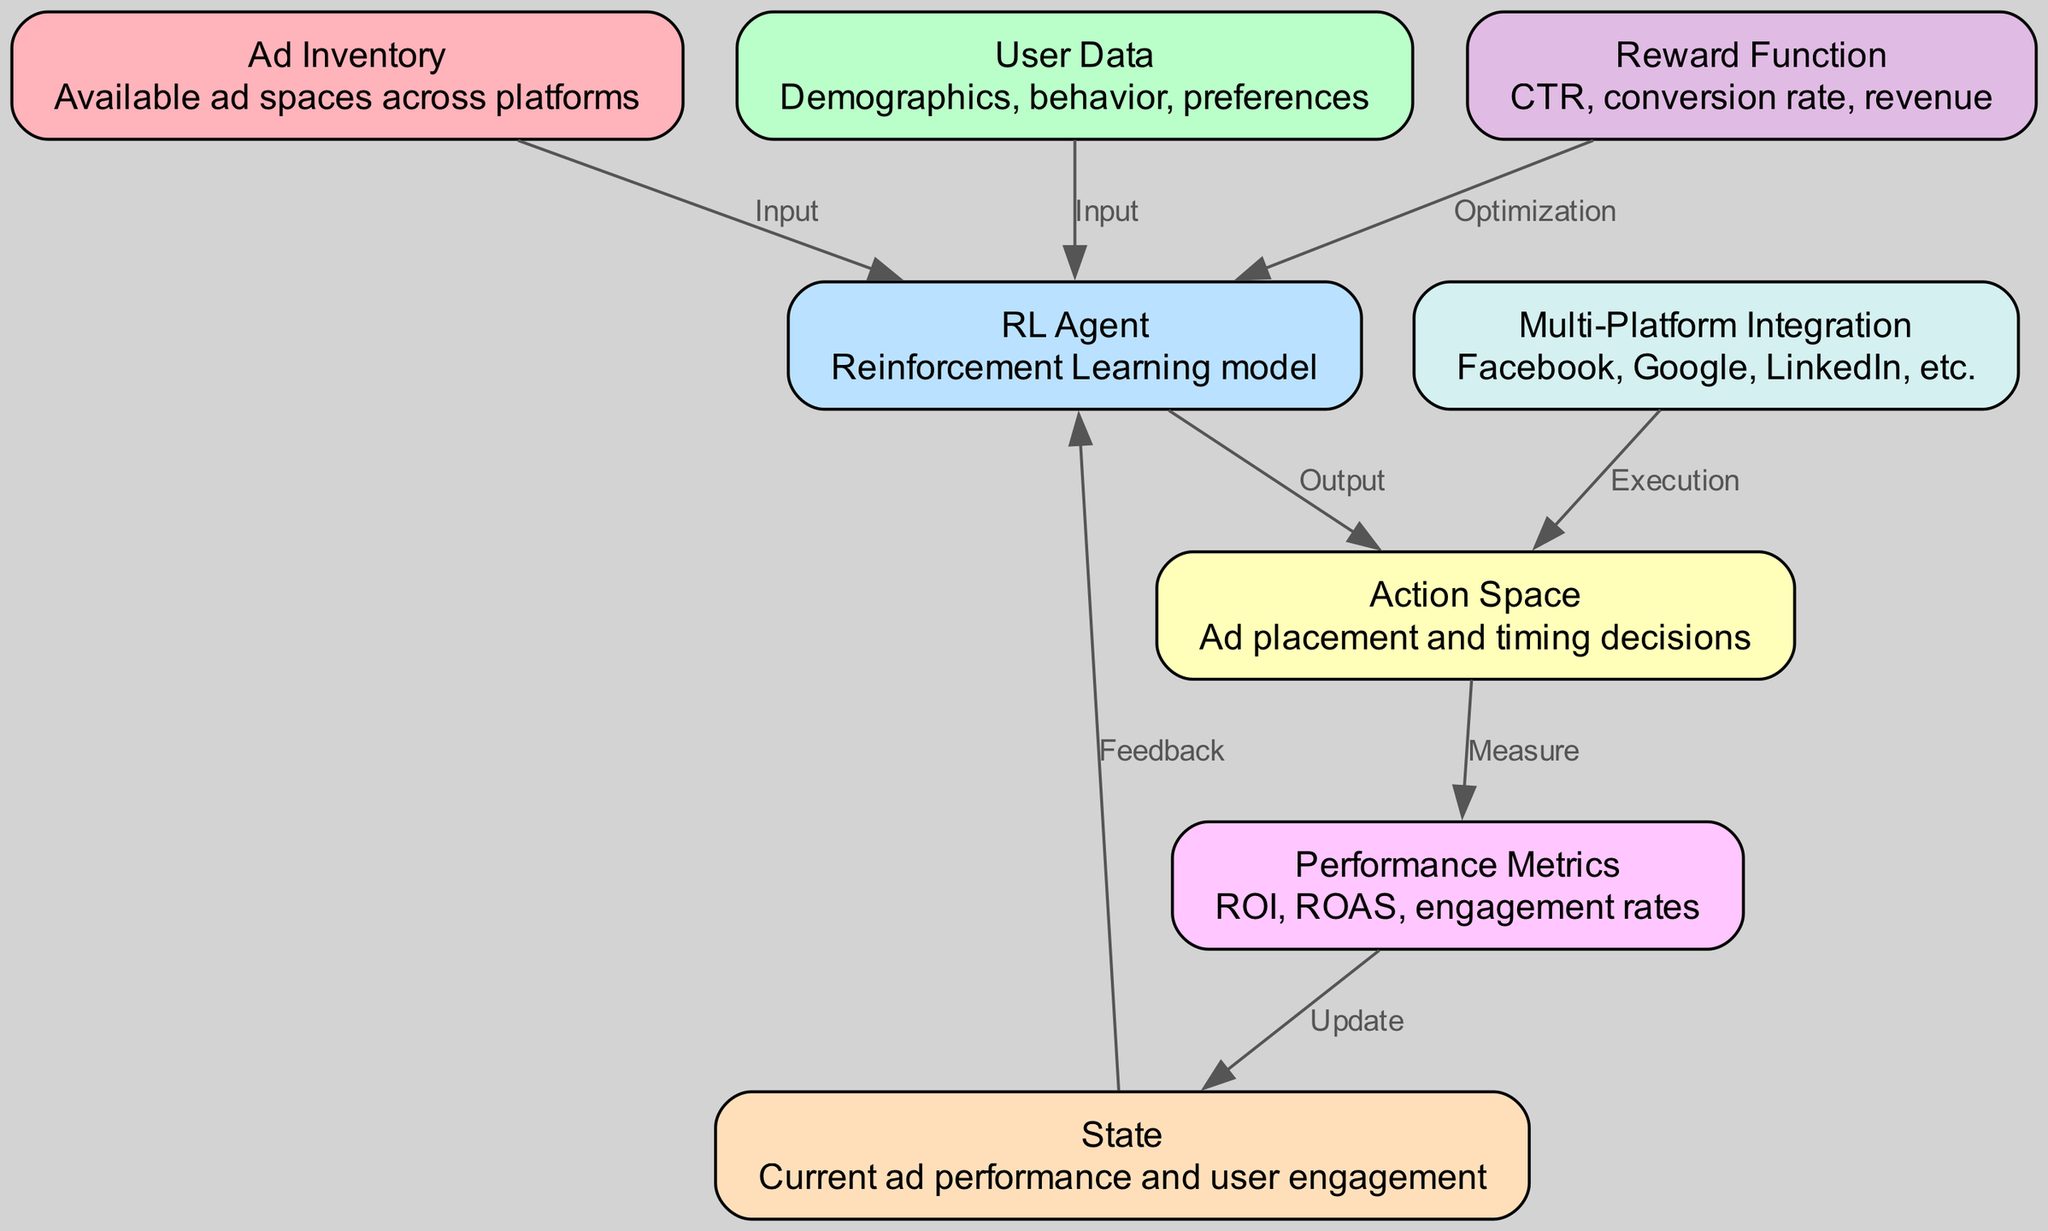What is the first node in the diagram? The first node is labeled 'Ad Inventory', which represents the available ad spaces across platforms.
Answer: Ad Inventory How many nodes are present in the diagram? The diagram contains a total of 8 nodes, each representing different components of the reinforcement learning model for ad optimization.
Answer: 8 What connects 'User Data' and 'RL Agent'? The edge labeled 'Input' connects 'User Data' and 'RL Agent', indicating that user demographics and preferences are input to the reinforcement learning model.
Answer: Input What is the role of the 'Reward Function'? The 'Reward Function' receives input from current ad performance metrics and provides optimization feedback to the 'RL Agent', impacting its learning.
Answer: Optimization How is 'Performance Metrics' related to 'State'? 'Performance Metrics' affects the 'State' by providing updated performance data based on the ad placement and timing decisions made by the 'RL Agent'.
Answer: Update What type of data does the 'RL Agent' process? The 'RL Agent' processes input data from both the 'Ad Inventory' and 'User Data' to learn and optimize ad placements.
Answer: Input What is the final outcome measured in the diagram? The final outcome measured in the diagram is 'Performance Metrics', which evaluates the effectiveness of ad placement in terms of ROI, ROAS, and engagement rates.
Answer: Performance Metrics What platform integrations are indicated in the diagram? The diagram mentions 'Multi-Platform Integration', which includes Facebook, Google, LinkedIn, etc., signifying the various platforms where ads can be placed.
Answer: Facebook, Google, LinkedIn How is the 'Action Space' defined? The 'Action Space' is defined as the choices related to ad placement and timing decisions made by the 'RL Agent' in response to the state feedback and performance metrics.
Answer: Ad placement and timing decisions 